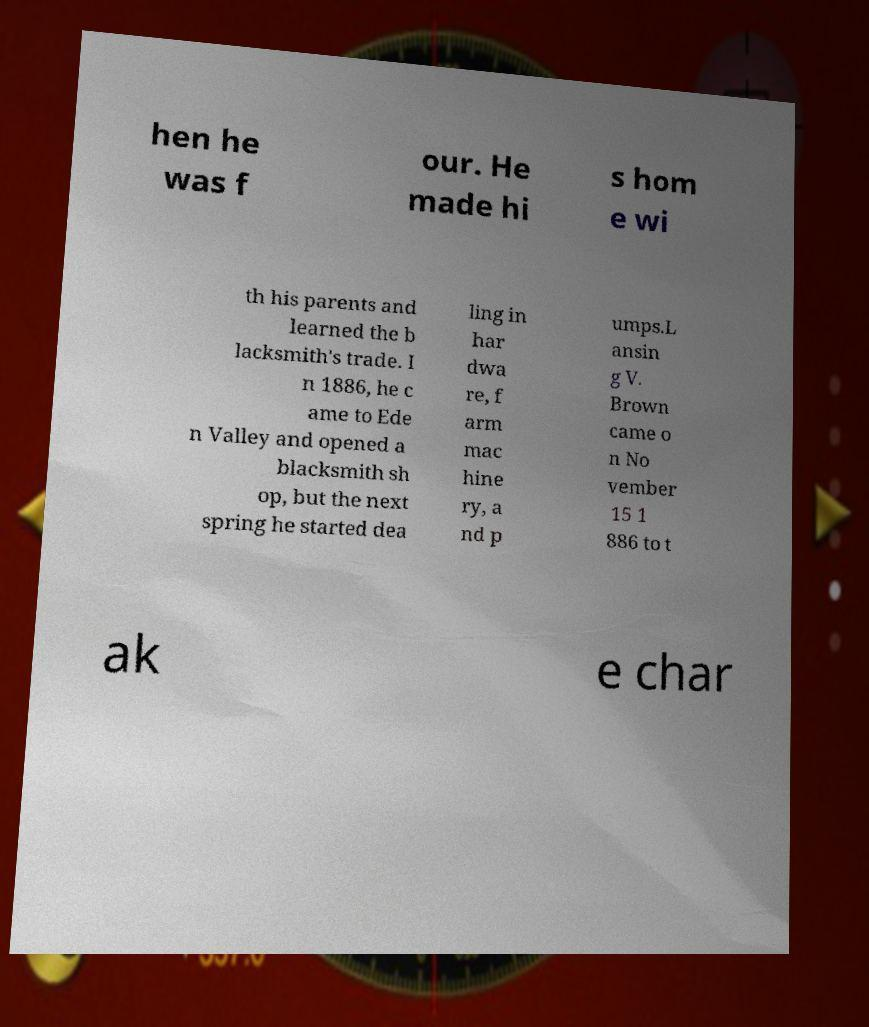Can you read and provide the text displayed in the image?This photo seems to have some interesting text. Can you extract and type it out for me? hen he was f our. He made hi s hom e wi th his parents and learned the b lacksmith's trade. I n 1886, he c ame to Ede n Valley and opened a blacksmith sh op, but the next spring he started dea ling in har dwa re, f arm mac hine ry, a nd p umps.L ansin g V. Brown came o n No vember 15 1 886 to t ak e char 